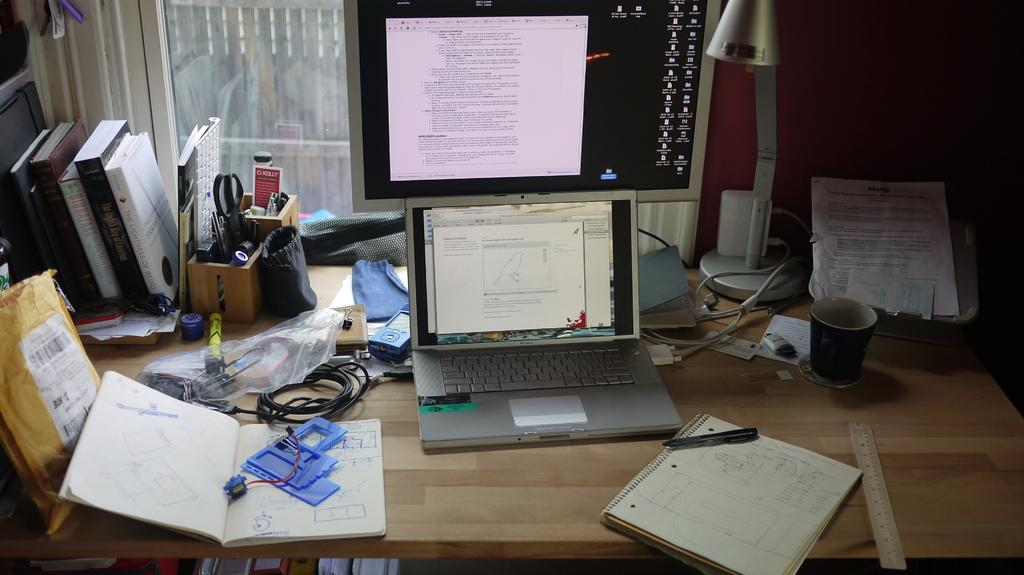What electronic device is visible in the image? There is a laptop in the image. What other electronic device can be seen in the image? There is a monitor in the image. What type of object is present in the image that is not electronic? There is a box in the image. What items are present in the image that are not electronic devices or boxes? There are papers and cups in the image. How many boxes are visible in the image? There are boxes in the image. What is the source of light in the image? There is a light in the image. What type of authority figure is present in the image? There is no authority figure present in the image. What is the hammer used for in the image? There is no hammer present in the image. 